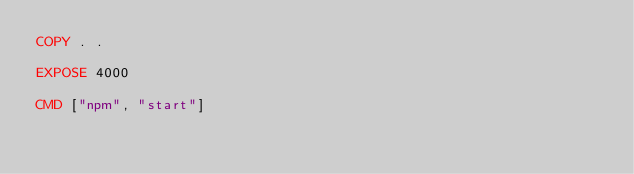<code> <loc_0><loc_0><loc_500><loc_500><_Dockerfile_>COPY . .

EXPOSE 4000

CMD ["npm", "start"]</code> 